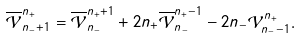Convert formula to latex. <formula><loc_0><loc_0><loc_500><loc_500>\overline { \mathcal { V } } _ { n _ { - } + 1 } ^ { n _ { + } } = \overline { \mathcal { V } } _ { n _ { - } } ^ { n _ { + } + 1 } + 2 n _ { + } \overline { \mathcal { V } } _ { n _ { - } } ^ { n _ { + } - 1 } - 2 n _ { - } \mathcal { V } _ { n _ { - } - 1 } ^ { n _ { + } } .</formula> 